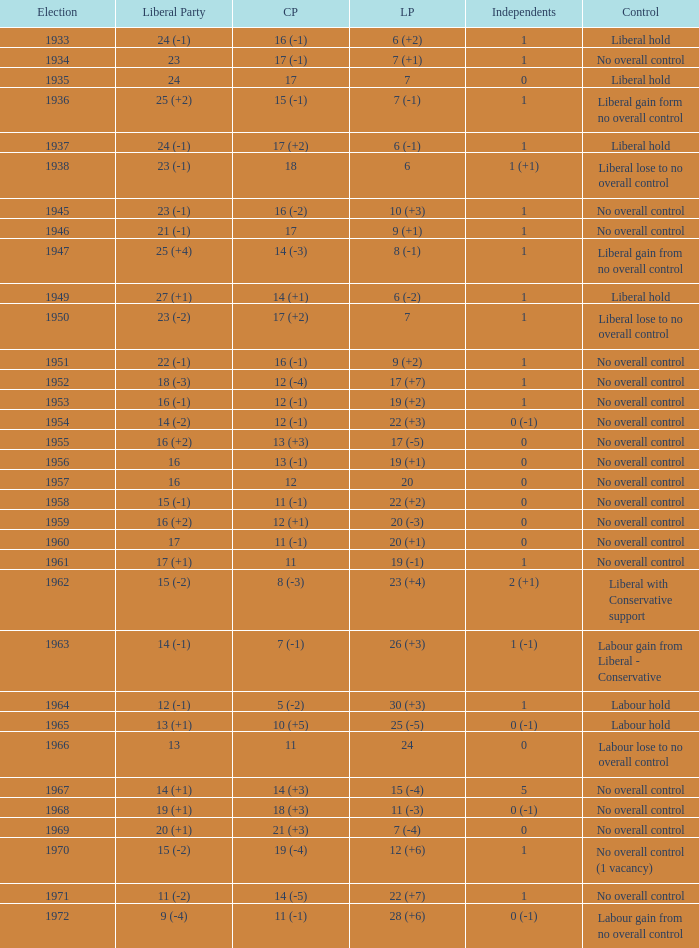What was the Liberal Party result from the election having a Conservative Party result of 16 (-1) and Labour of 6 (+2)? 24 (-1). Would you mind parsing the complete table? {'header': ['Election', 'Liberal Party', 'CP', 'LP', 'Independents', 'Control'], 'rows': [['1933', '24 (-1)', '16 (-1)', '6 (+2)', '1', 'Liberal hold'], ['1934', '23', '17 (-1)', '7 (+1)', '1', 'No overall control'], ['1935', '24', '17', '7', '0', 'Liberal hold'], ['1936', '25 (+2)', '15 (-1)', '7 (-1)', '1', 'Liberal gain form no overall control'], ['1937', '24 (-1)', '17 (+2)', '6 (-1)', '1', 'Liberal hold'], ['1938', '23 (-1)', '18', '6', '1 (+1)', 'Liberal lose to no overall control'], ['1945', '23 (-1)', '16 (-2)', '10 (+3)', '1', 'No overall control'], ['1946', '21 (-1)', '17', '9 (+1)', '1', 'No overall control'], ['1947', '25 (+4)', '14 (-3)', '8 (-1)', '1', 'Liberal gain from no overall control'], ['1949', '27 (+1)', '14 (+1)', '6 (-2)', '1', 'Liberal hold'], ['1950', '23 (-2)', '17 (+2)', '7', '1', 'Liberal lose to no overall control'], ['1951', '22 (-1)', '16 (-1)', '9 (+2)', '1', 'No overall control'], ['1952', '18 (-3)', '12 (-4)', '17 (+7)', '1', 'No overall control'], ['1953', '16 (-1)', '12 (-1)', '19 (+2)', '1', 'No overall control'], ['1954', '14 (-2)', '12 (-1)', '22 (+3)', '0 (-1)', 'No overall control'], ['1955', '16 (+2)', '13 (+3)', '17 (-5)', '0', 'No overall control'], ['1956', '16', '13 (-1)', '19 (+1)', '0', 'No overall control'], ['1957', '16', '12', '20', '0', 'No overall control'], ['1958', '15 (-1)', '11 (-1)', '22 (+2)', '0', 'No overall control'], ['1959', '16 (+2)', '12 (+1)', '20 (-3)', '0', 'No overall control'], ['1960', '17', '11 (-1)', '20 (+1)', '0', 'No overall control'], ['1961', '17 (+1)', '11', '19 (-1)', '1', 'No overall control'], ['1962', '15 (-2)', '8 (-3)', '23 (+4)', '2 (+1)', 'Liberal with Conservative support'], ['1963', '14 (-1)', '7 (-1)', '26 (+3)', '1 (-1)', 'Labour gain from Liberal - Conservative'], ['1964', '12 (-1)', '5 (-2)', '30 (+3)', '1', 'Labour hold'], ['1965', '13 (+1)', '10 (+5)', '25 (-5)', '0 (-1)', 'Labour hold'], ['1966', '13', '11', '24', '0', 'Labour lose to no overall control'], ['1967', '14 (+1)', '14 (+3)', '15 (-4)', '5', 'No overall control'], ['1968', '19 (+1)', '18 (+3)', '11 (-3)', '0 (-1)', 'No overall control'], ['1969', '20 (+1)', '21 (+3)', '7 (-4)', '0', 'No overall control'], ['1970', '15 (-2)', '19 (-4)', '12 (+6)', '1', 'No overall control (1 vacancy)'], ['1971', '11 (-2)', '14 (-5)', '22 (+7)', '1', 'No overall control'], ['1972', '9 (-4)', '11 (-1)', '28 (+6)', '0 (-1)', 'Labour gain from no overall control']]} 